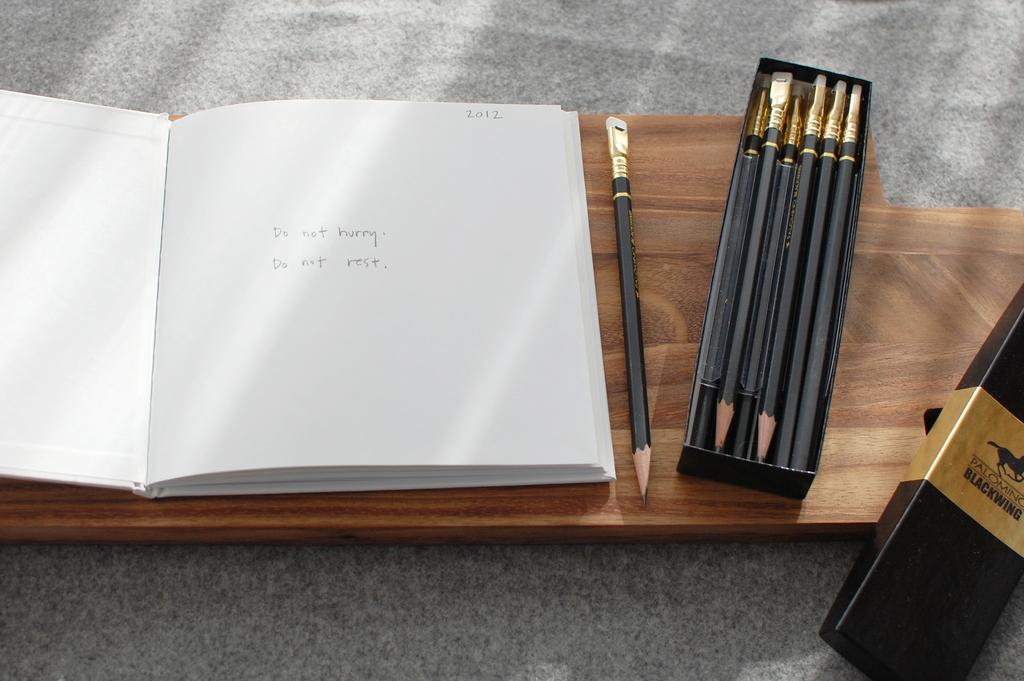What object can be seen in the image that is typically used for reading and learning? There is a book in the image. What object is present in the image that is commonly used for storing writing utensils? There is a pencil box in the image. Where are the book and pencil box placed in the image? The book and pencil box are placed on a wooden plank. What type of surface is visible at the bottom of the image? The bottom of the image appears to be sand. What page of the book is currently being read in the image? The image does not show any specific page being read; it only shows the book and pencil box on the wooden plank. 